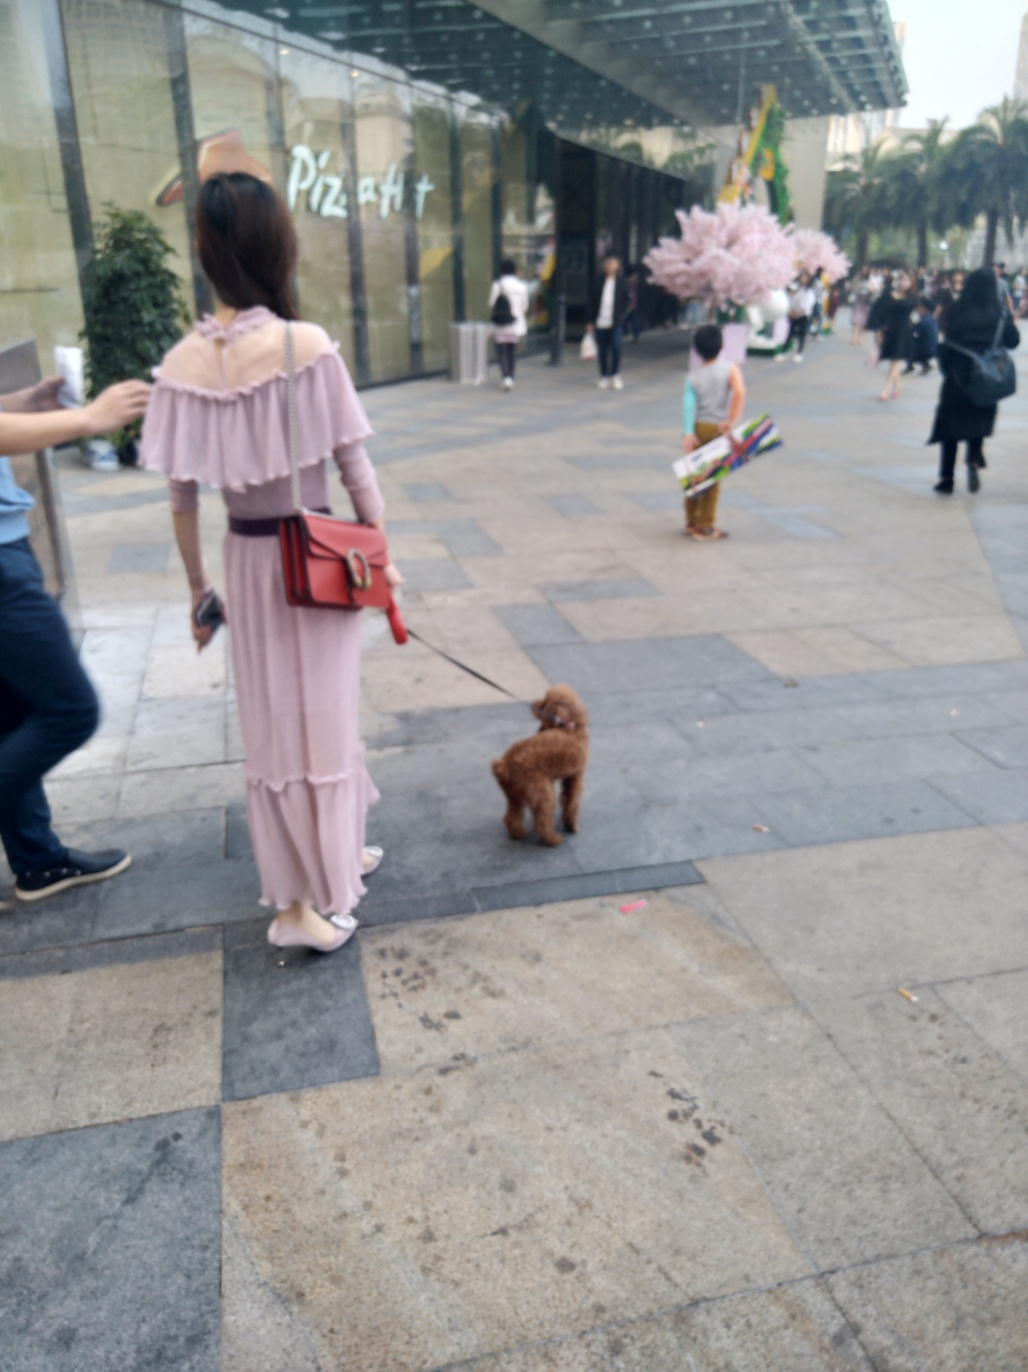Can you provide a description of what the child in the center is holding? The child appears to be holding an object that is both colorful and elongated; it resembles a set of play swords or sticks, commonly associated with children's games or activities. 